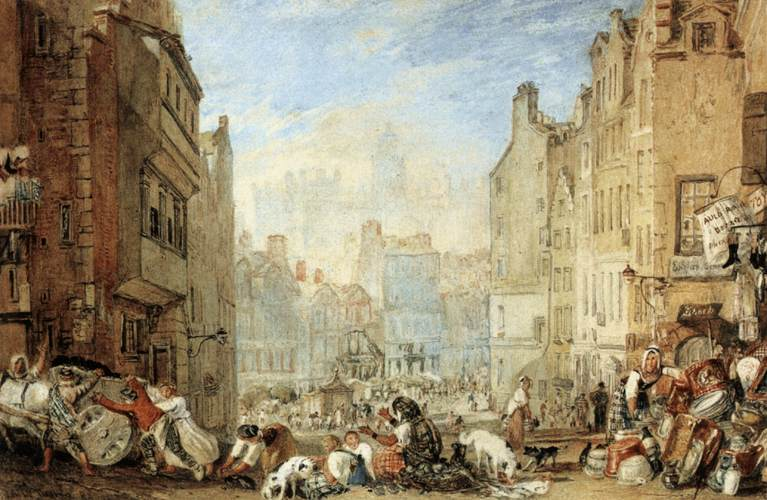Can you provide more detail on the architecture shown in the image? Certainly. The buildings depicted exhibit characteristics typical of historic European architecture, such as pitched roofs, tall and narrow facades, and a usage of brick or stone. The windows are small and unevenly placed, and shop signs protrude into the street, indicating a time before modern planning. Some buildings have visible timber framing which could suggest Tudor style, popular in certain areas during the late medieval period. The sense of wear and patchwork repair on some buildings tells us these structures have seen many years, perhaps even centuries, and have played host to countless human stories. 